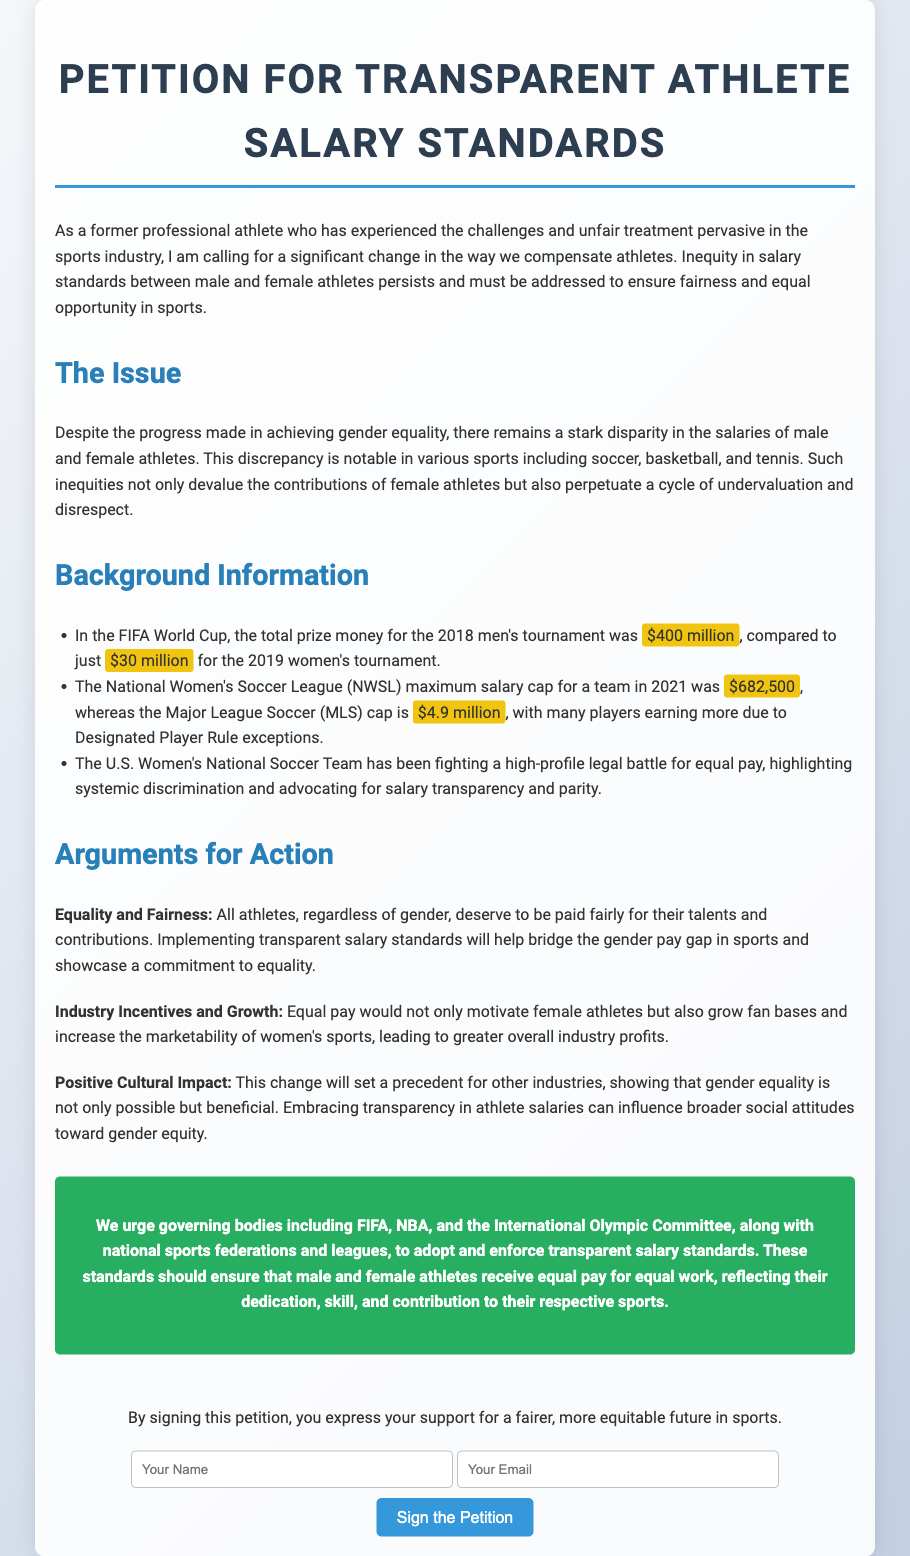What is the title of the petition? The title of the petition is stated at the top of the document.
Answer: Petition for Transparent Athlete Salary Standards What was the total prize money for the 2018 men's FIFA World Cup? The document provides specific prize money amounts for the tournaments.
Answer: $400 million What was the maximum salary cap for the National Women's Soccer League in 2021? The document lists the maximum salary cap for teams in the NWSL for that year.
Answer: $682,500 What event did the U.S. Women's National Soccer Team fight a legal battle for? The document discusses a notable legal battle involving the U.S. Women's National Soccer Team.
Answer: Equal pay Which governing bodies are urged to adopt transparent salary standards? The document mentions specific organizations that are urged for change.
Answer: FIFA, NBA, International Olympic Committee What is one of the arguments for action mentioned in the petition? The document outlines various arguments for implementing salary standards.
Answer: Equality and Fairness What is the purpose of signing the petition? The document clarifies what supporters express by signing.
Answer: Support for a fairer, more equitable future in sports What color is used for the 'call-to-action' section? The document describes the styling of specific sections, including color.
Answer: Green 